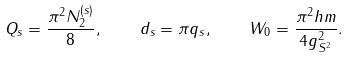Convert formula to latex. <formula><loc_0><loc_0><loc_500><loc_500>Q _ { s } = \frac { \pi ^ { 2 } N _ { 2 } ^ { ( s ) } } { 8 } , \quad d _ { s } = \pi q _ { s } , \quad W _ { 0 } = \frac { \pi ^ { 2 } h m } { 4 g _ { S ^ { 2 } } ^ { 2 } } .</formula> 